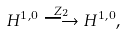<formula> <loc_0><loc_0><loc_500><loc_500>H ^ { 1 , 0 } \overset { Z _ { 2 } } \longrightarrow H ^ { 1 , 0 } ,</formula> 